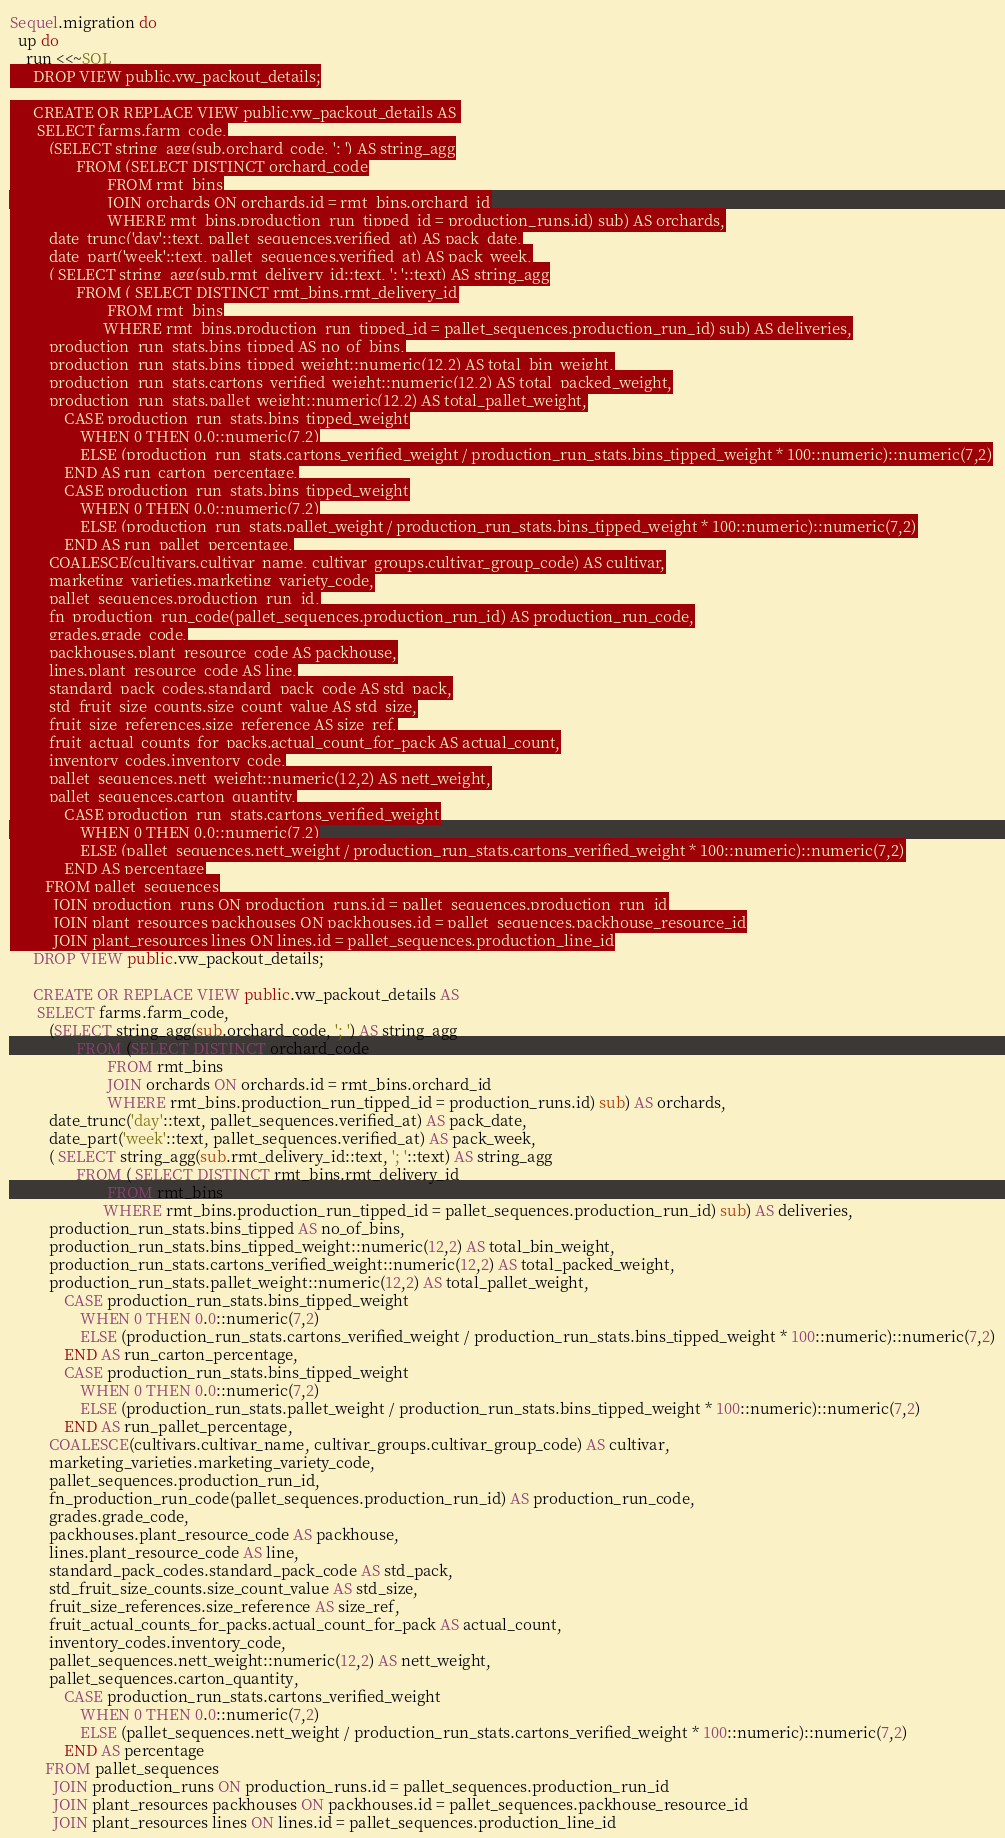<code> <loc_0><loc_0><loc_500><loc_500><_Ruby_>Sequel.migration do
  up do
    run <<~SQL
      DROP VIEW public.vw_packout_details;

      CREATE OR REPLACE VIEW public.vw_packout_details AS 
       SELECT farms.farm_code,
          (SELECT string_agg(sub.orchard_code, '; ') AS string_agg
                 FROM (SELECT DISTINCT orchard_code
                         FROM rmt_bins
                         JOIN orchards ON orchards.id = rmt_bins.orchard_id
                         WHERE rmt_bins.production_run_tipped_id = production_runs.id) sub) AS orchards,
          date_trunc('day'::text, pallet_sequences.verified_at) AS pack_date,
          date_part('week'::text, pallet_sequences.verified_at) AS pack_week,
          ( SELECT string_agg(sub.rmt_delivery_id::text, '; '::text) AS string_agg
                 FROM ( SELECT DISTINCT rmt_bins.rmt_delivery_id
                         FROM rmt_bins
                        WHERE rmt_bins.production_run_tipped_id = pallet_sequences.production_run_id) sub) AS deliveries,
          production_run_stats.bins_tipped AS no_of_bins,
          production_run_stats.bins_tipped_weight::numeric(12,2) AS total_bin_weight,
          production_run_stats.cartons_verified_weight::numeric(12,2) AS total_packed_weight,
          production_run_stats.pallet_weight::numeric(12,2) AS total_pallet_weight,
              CASE production_run_stats.bins_tipped_weight
                  WHEN 0 THEN 0.0::numeric(7,2)
                  ELSE (production_run_stats.cartons_verified_weight / production_run_stats.bins_tipped_weight * 100::numeric)::numeric(7,2)
              END AS run_carton_percentage,
              CASE production_run_stats.bins_tipped_weight
                  WHEN 0 THEN 0.0::numeric(7,2)
                  ELSE (production_run_stats.pallet_weight / production_run_stats.bins_tipped_weight * 100::numeric)::numeric(7,2)
              END AS run_pallet_percentage,
          COALESCE(cultivars.cultivar_name, cultivar_groups.cultivar_group_code) AS cultivar,
          marketing_varieties.marketing_variety_code,
          pallet_sequences.production_run_id,
          fn_production_run_code(pallet_sequences.production_run_id) AS production_run_code,
          grades.grade_code,
          packhouses.plant_resource_code AS packhouse,
          lines.plant_resource_code AS line,
          standard_pack_codes.standard_pack_code AS std_pack,
          std_fruit_size_counts.size_count_value AS std_size,
          fruit_size_references.size_reference AS size_ref,
          fruit_actual_counts_for_packs.actual_count_for_pack AS actual_count,
          inventory_codes.inventory_code,
          pallet_sequences.nett_weight::numeric(12,2) AS nett_weight,
          pallet_sequences.carton_quantity,
              CASE production_run_stats.cartons_verified_weight
                  WHEN 0 THEN 0.0::numeric(7,2)
                  ELSE (pallet_sequences.nett_weight / production_run_stats.cartons_verified_weight * 100::numeric)::numeric(7,2)
              END AS percentage
         FROM pallet_sequences
           JOIN production_runs ON production_runs.id = pallet_sequences.production_run_id
           JOIN plant_resources packhouses ON packhouses.id = pallet_sequences.packhouse_resource_id
           JOIN plant_resources lines ON lines.id = pallet_sequences.production_line_id</code> 